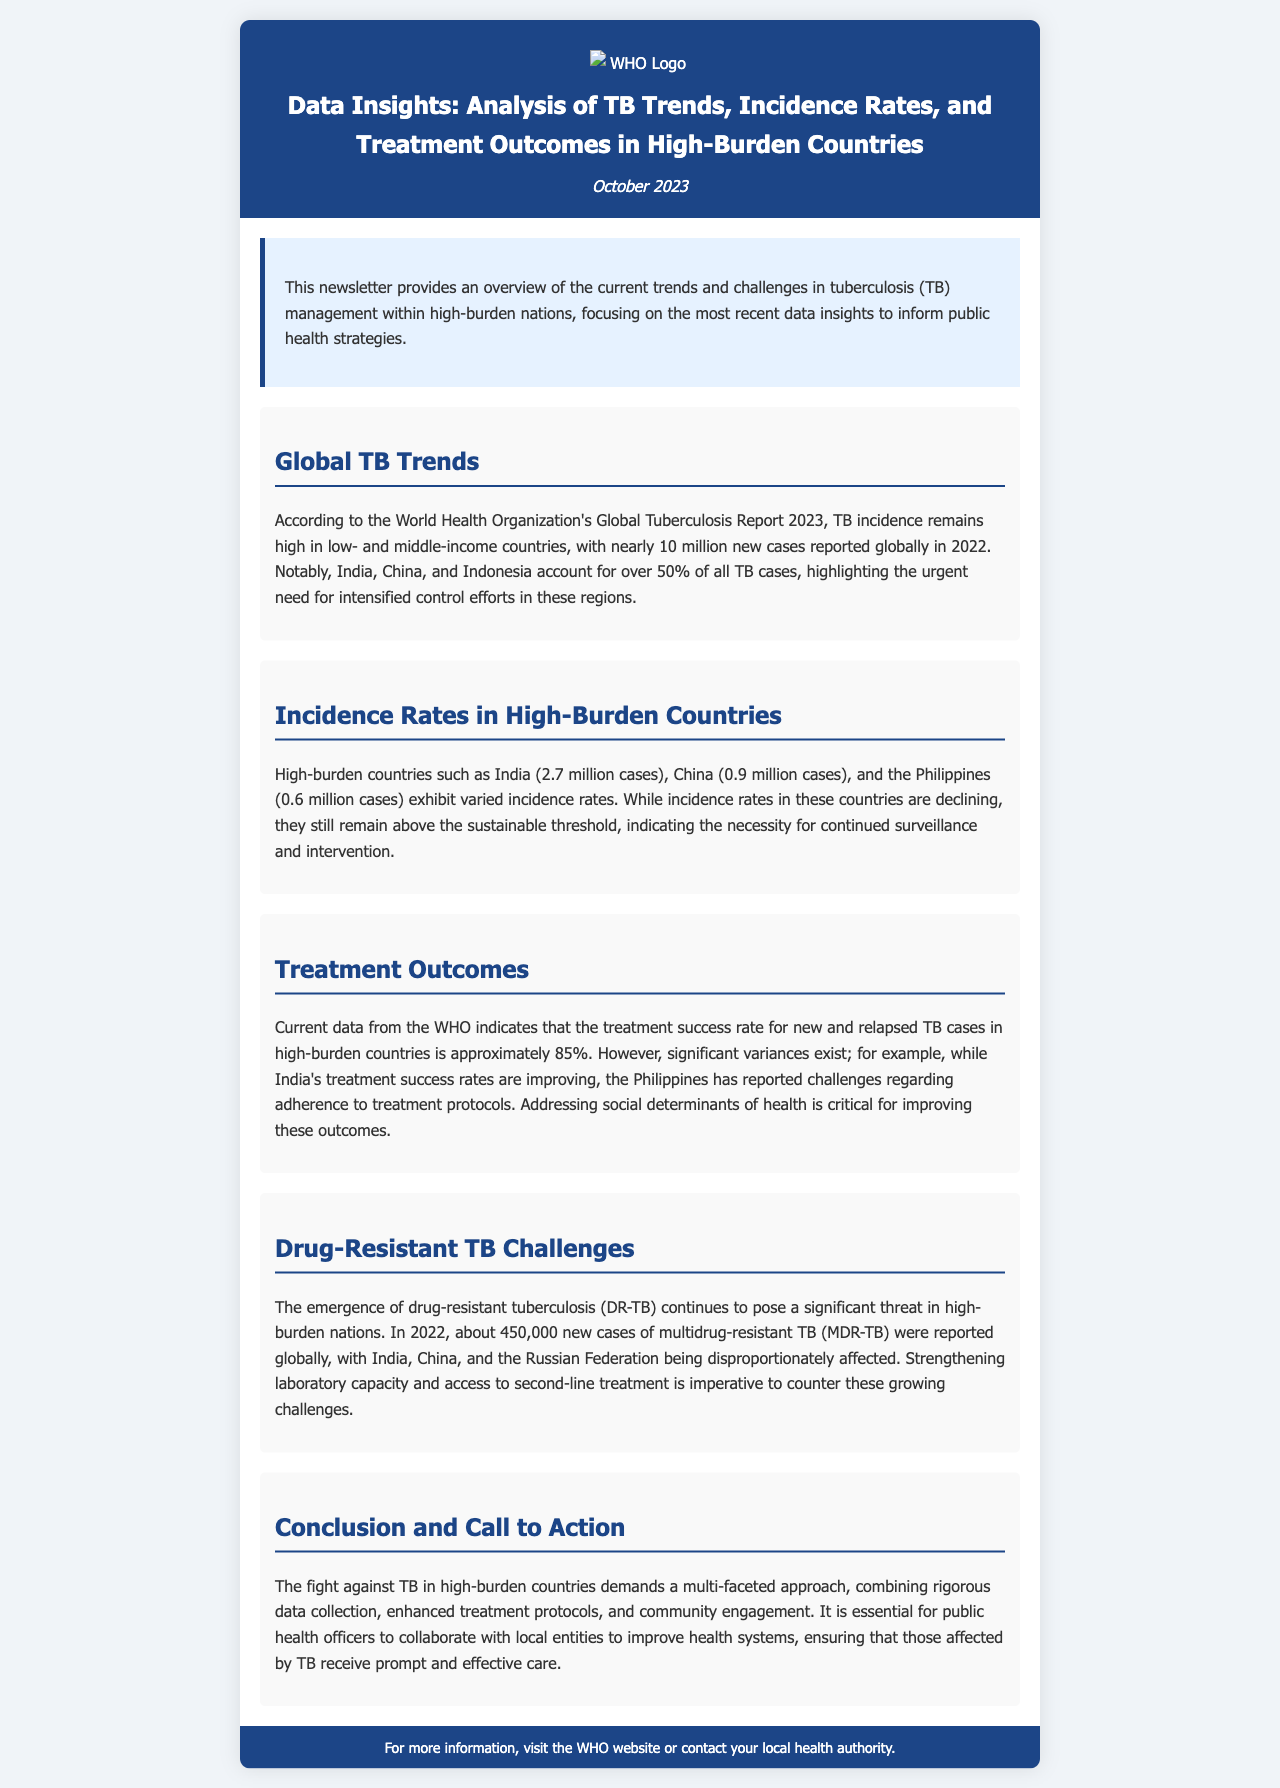What is the publication date of the newsletter? The publication date is mentioned in the header of the document.
Answer: October 2023 How many new TB cases were reported globally in 2022? This information is stated in the section about global TB trends.
Answer: 10 million Which country has the highest number of TB cases according to the newsletter? The newsletter lists the number of cases for multiple countries and identifies the one with the highest count.
Answer: India What is the treatment success rate for new and relapsed TB cases? The treatment success rate is mentioned in the treatment outcomes section of the document.
Answer: Approximately 85% Name one country struggling with adherence to treatment protocols. The newsletter specifies issues regarding adherence to treatment protocols for one particular country.
Answer: Philippines What type of TB continues to pose a significant threat in high-burden nations? The document indicates the type of TB that presents challenges in these regions.
Answer: Drug-resistant tuberculosis How many new cases of multidrug-resistant TB were reported globally in 2022? This figure is provided in the section discussing drug-resistant TB challenges.
Answer: About 450,000 What is emphasized as critical for improving treatment outcomes? The conclusion section highlights an important factor for improving treatment outcomes.
Answer: Addressing social determinants of health Which countries account for over 50% of all TB cases? The document lists countries that collectively hold a significant percentage of total cases.
Answer: India, China, Indonesia What approach is deemed necessary in the conclusion? The conclusion summarizes the needed approach to combat TB effectively.
Answer: Multi-faceted approach 